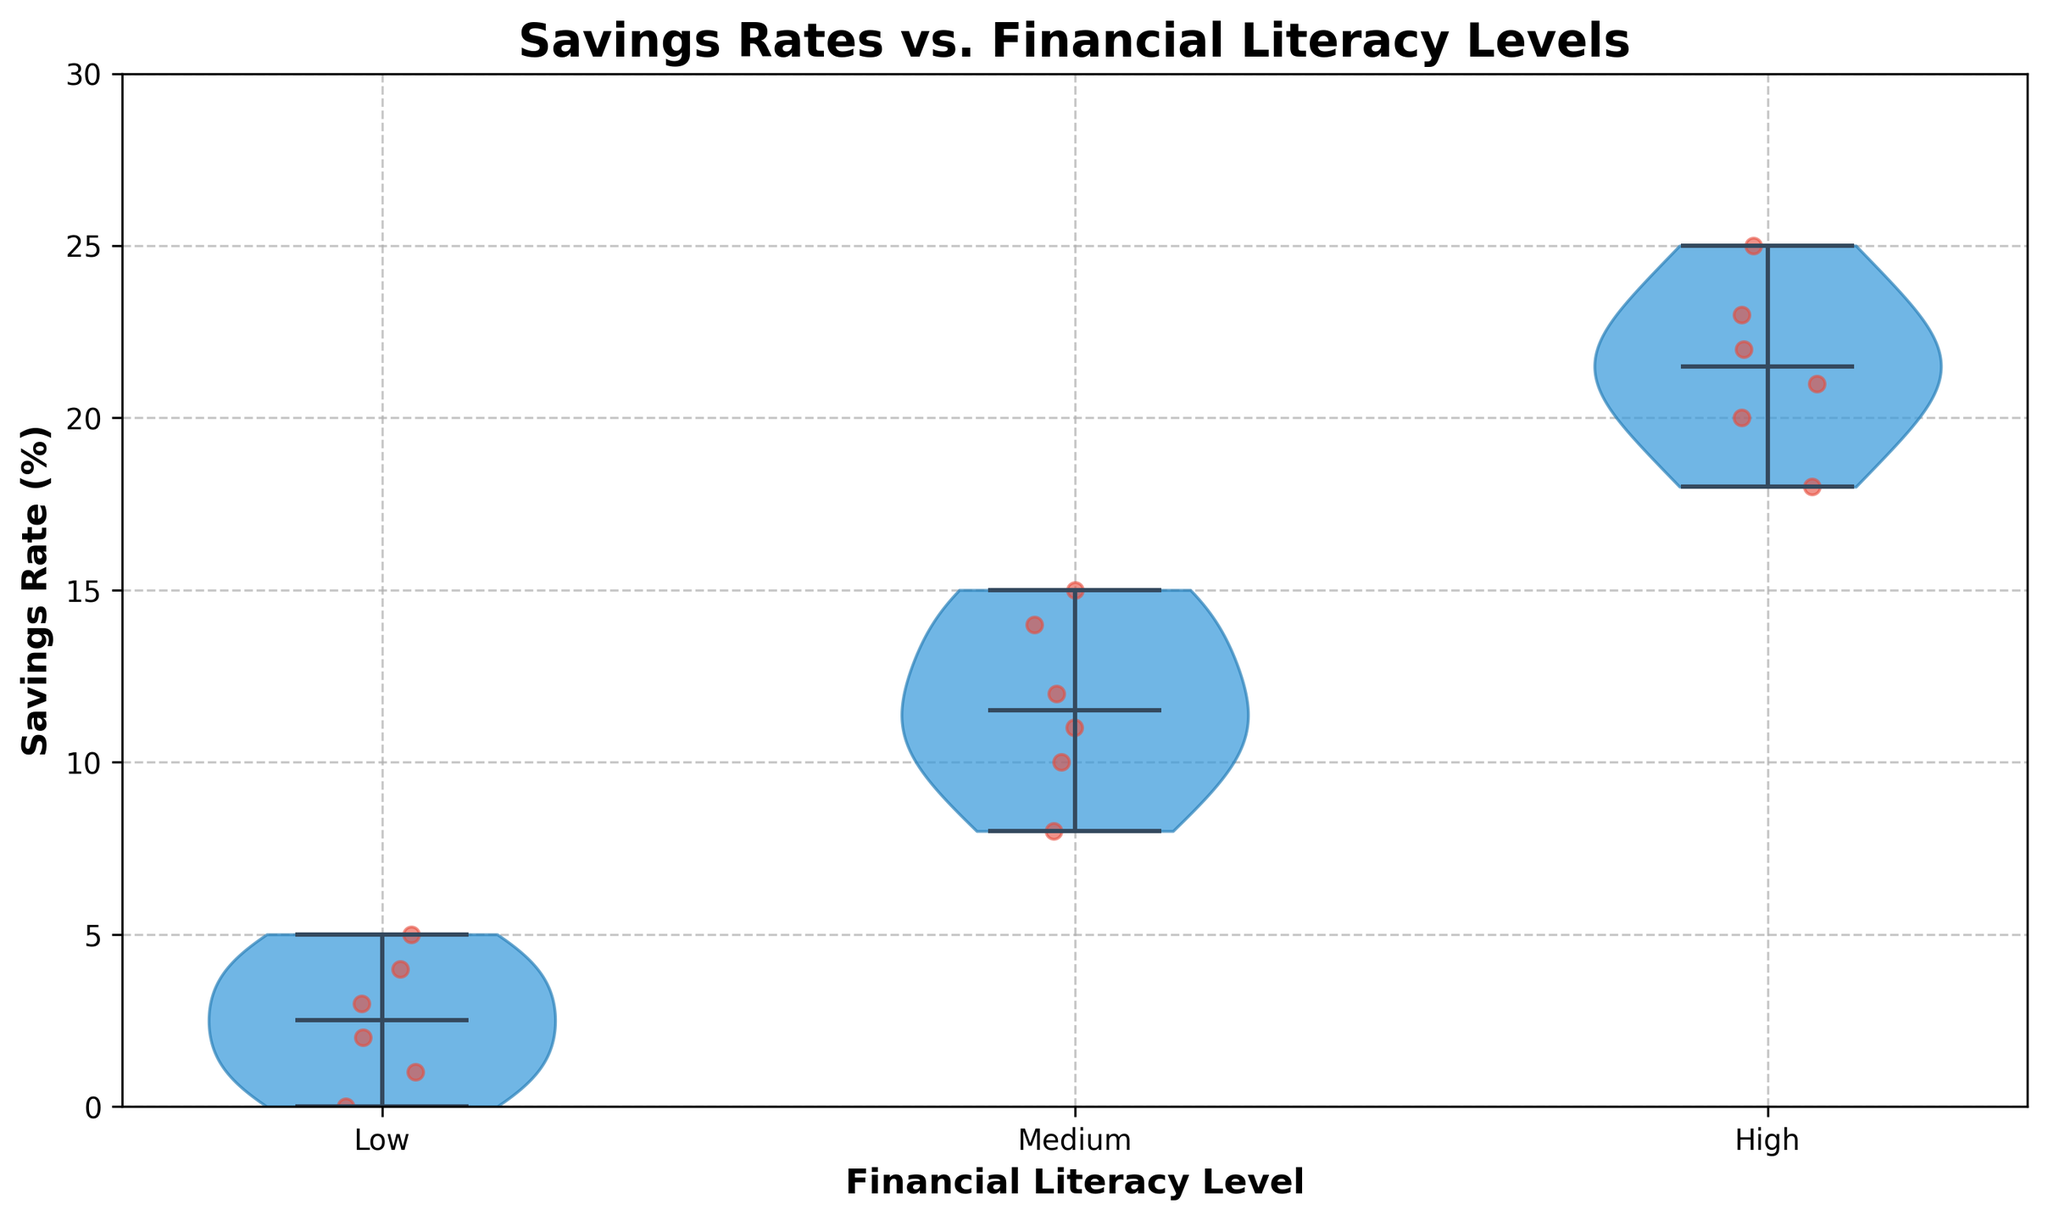What is the title of the figure? The title is located at the top of the figure, in bold text, and reads "Savings Rates vs. Financial Literacy Levels."
Answer: Savings Rates vs. Financial Literacy Levels What do the y-axis and x-axis represent in the plot? The labels on the axes indicate that the x-axis represents "Financial Literacy Level" and the y-axis represents "Savings Rate (%)."
Answer: x-axis: Financial Literacy Level, y-axis: Savings Rate (%) What colors are used for the violin plots and jittered points? The violin plots are shaded in blue with some transparency, while the jittered points are represented in red.
Answer: Blue and Red What are the three financial literacy levels shown on the x-axis? The x-axis labels indicate three financial literacy levels: Low, Medium, and High.
Answer: Low, Medium, High What is the range of the y-axis, and why might it have been chosen? The y-axis ranges from 0 to 30. This range encompasses all the data points to provide a clear visualization of savings rates and to ensure none of the points are cut off.
Answer: 0 to 30 Which financial literacy level appears to have the highest median savings rate? The median line in the violin plot for the "High" financial literacy level is positioned higher on the y-axis compared to the others.
Answer: High How does the spread of savings rates for the Low literacy level compare to that for the Medium level? The spread for the Low literacy level is much more compact and near the bottom compared to the wider range observed in the Medium level's violin plot.
Answer: Low level has a narrower spread What pattern can you observe about the savings rates as financial literacy levels change from Low to High? As financial literacy levels increase from Low to High, savings rates also increase, both in terms of median savings rates and the overall spread of the data.
Answer: Savings rates increase with higher financial literacy What is the approximate median savings rate for the Medium financial literacy level? The median savings rate for the Medium level, represented by the central line in the violin plot, appears to be just slightly above 11%.
Answer: Slightly above 11% How many points are visualized in the High financial literacy level violin plot, based on the jittered points? By counting the jittered red points within the "High" section of the plot, there are six distinct data points represented.
Answer: Six 